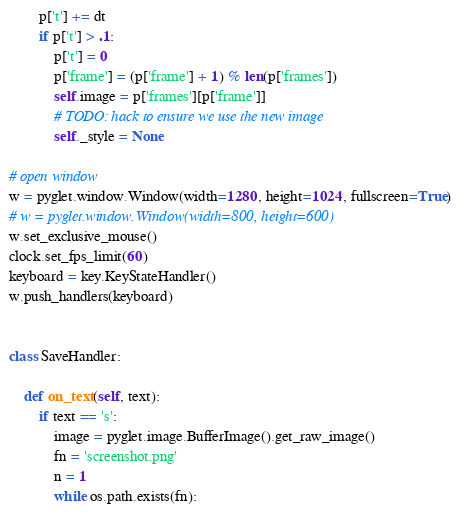Convert code to text. <code><loc_0><loc_0><loc_500><loc_500><_Python_>        p['t'] += dt
        if p['t'] > .1:
            p['t'] = 0
            p['frame'] = (p['frame'] + 1) % len(p['frames'])
            self.image = p['frames'][p['frame']]
            # TODO: hack to ensure we use the new image
            self._style = None

# open window
w = pyglet.window.Window(width=1280, height=1024, fullscreen=True)
# w = pyglet.window.Window(width=800, height=600)
w.set_exclusive_mouse()
clock.set_fps_limit(60)
keyboard = key.KeyStateHandler()
w.push_handlers(keyboard)


class SaveHandler:

    def on_text(self, text):
        if text == 's':
            image = pyglet.image.BufferImage().get_raw_image()
            fn = 'screenshot.png'
            n = 1
            while os.path.exists(fn):</code> 